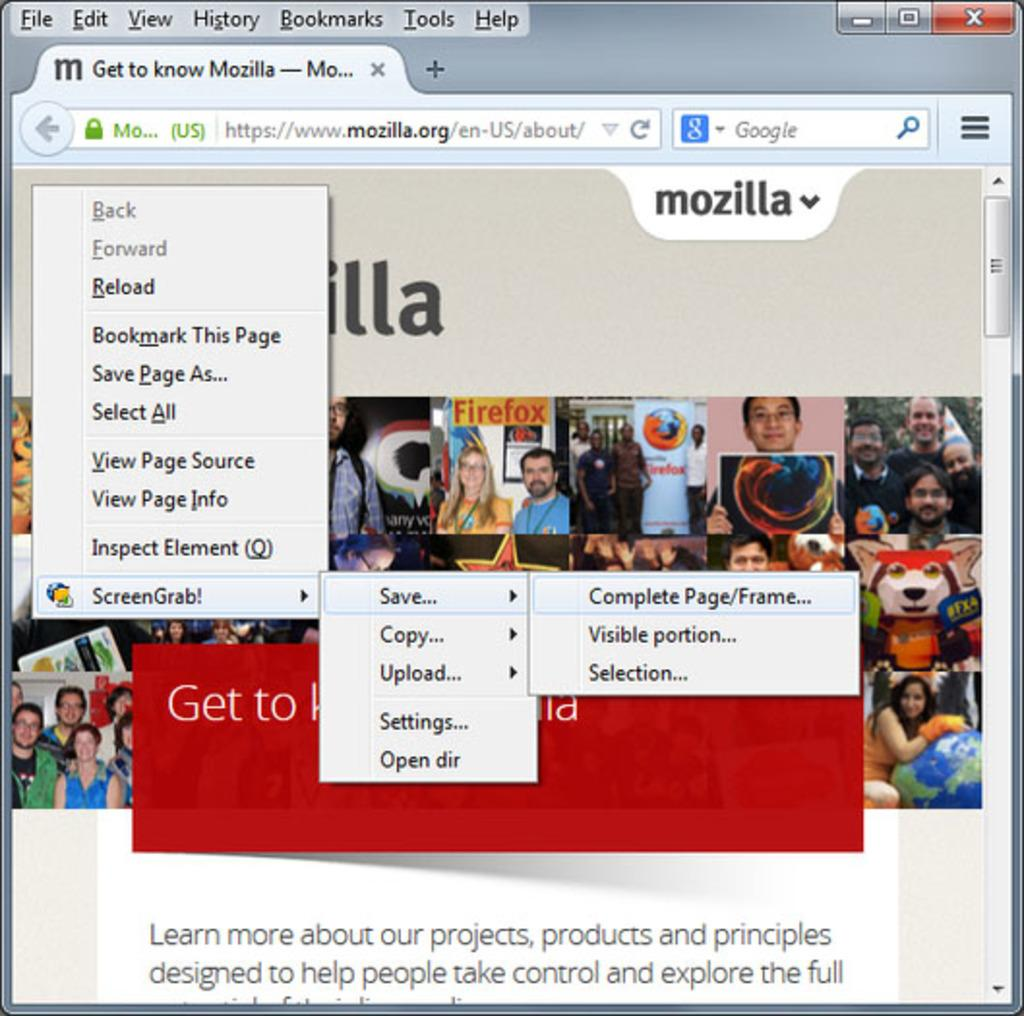What is the main object in the image? There is a desktop screen in the image. What can be seen on the screen? There is text and pictures visible on the screen. How much snow is visible on the desktop screen in the image? There is no snow visible on the desktop screen in the image. 